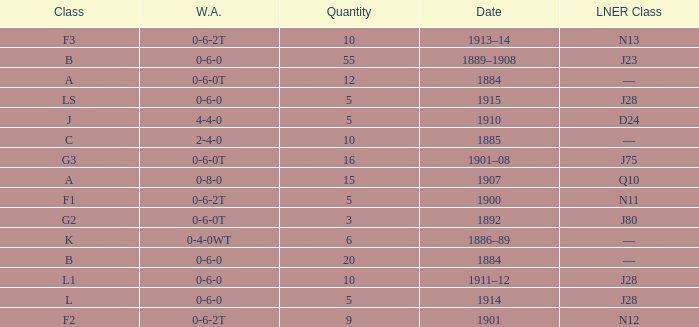What WA has a LNER Class of n13 and 10? 0-6-2T. 